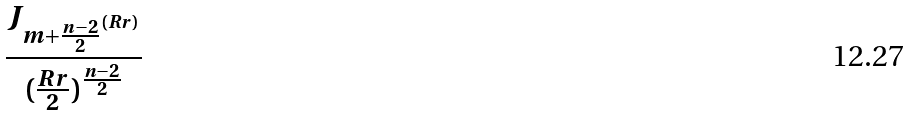Convert formula to latex. <formula><loc_0><loc_0><loc_500><loc_500>\frac { J _ { m + \frac { n - 2 } { 2 } ^ { ( R r ) } } } { ( \frac { R r } { 2 } ) ^ { \frac { n - 2 } { 2 } } }</formula> 